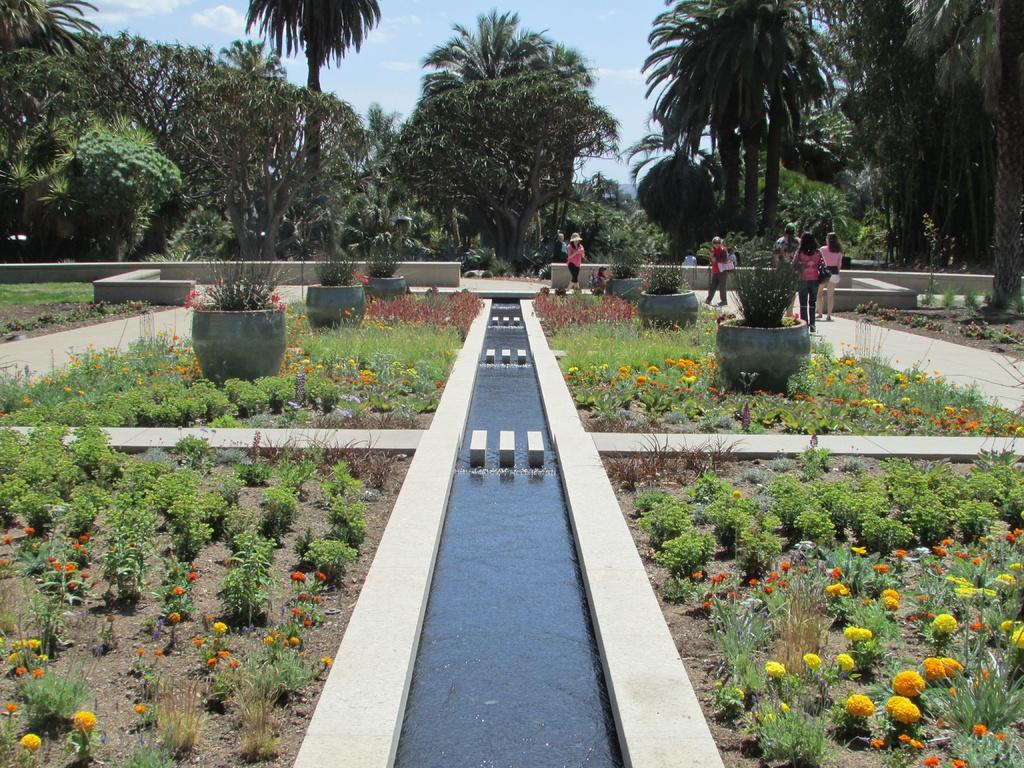What type of plants can be seen in the image? There are potted plants and plants with flowers on the ground in the image. What are the people in the image doing? There are people walking on the road in the image. What can be seen in the background of the image? Trees and the sky are visible in the background of the image. What type of system is being used by the plants to communicate with each other in the image? There is no indication in the image that the plants are communicating with each other or using any system to do so. 